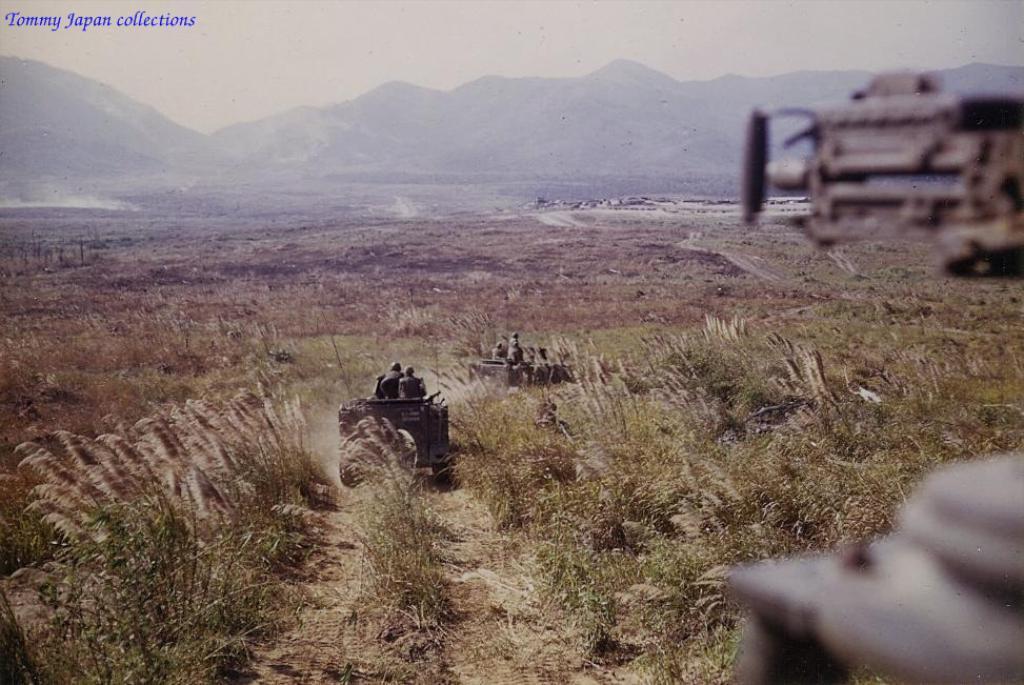Describe this image in one or two sentences. In the picture I can see some army vehicles are on the grass, side we can see ground. 